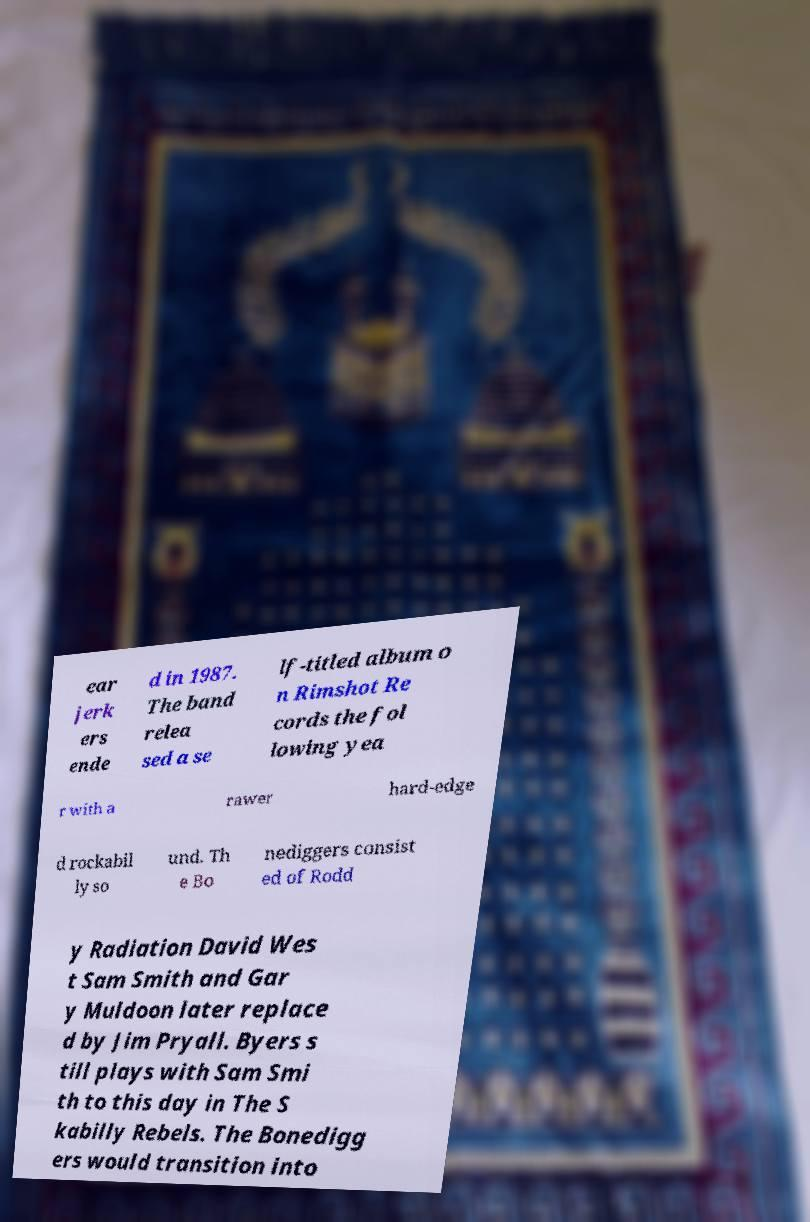Could you extract and type out the text from this image? ear jerk ers ende d in 1987. The band relea sed a se lf-titled album o n Rimshot Re cords the fol lowing yea r with a rawer hard-edge d rockabil ly so und. Th e Bo nediggers consist ed of Rodd y Radiation David Wes t Sam Smith and Gar y Muldoon later replace d by Jim Pryall. Byers s till plays with Sam Smi th to this day in The S kabilly Rebels. The Bonedigg ers would transition into 